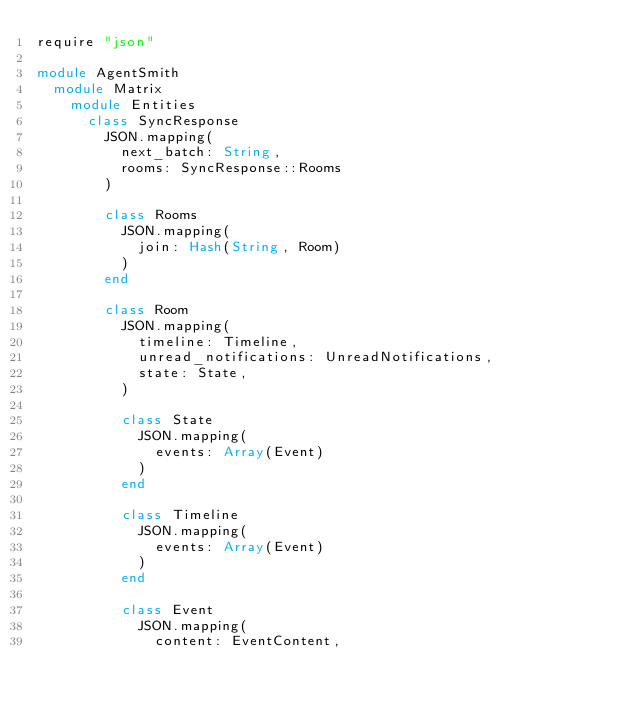Convert code to text. <code><loc_0><loc_0><loc_500><loc_500><_Crystal_>require "json"

module AgentSmith
  module Matrix
    module Entities
      class SyncResponse
        JSON.mapping(
          next_batch: String,
          rooms: SyncResponse::Rooms
        )

        class Rooms
          JSON.mapping(
            join: Hash(String, Room)
          )
        end

        class Room
          JSON.mapping(
            timeline: Timeline,
            unread_notifications: UnreadNotifications,
            state: State,
          )

          class State
            JSON.mapping(
              events: Array(Event)
            )
          end

          class Timeline
            JSON.mapping(
              events: Array(Event)
            )
          end

          class Event
            JSON.mapping(
              content: EventContent,</code> 